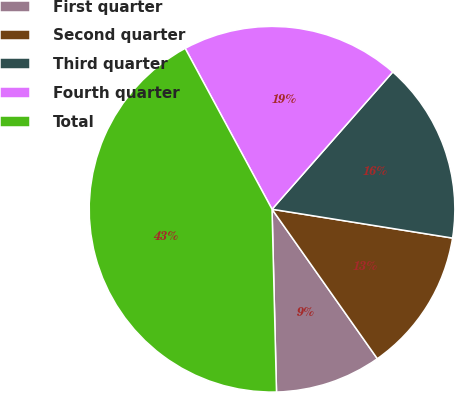Convert chart to OTSL. <chart><loc_0><loc_0><loc_500><loc_500><pie_chart><fcel>First quarter<fcel>Second quarter<fcel>Third quarter<fcel>Fourth quarter<fcel>Total<nl><fcel>9.38%<fcel>12.71%<fcel>16.04%<fcel>19.36%<fcel>42.51%<nl></chart> 